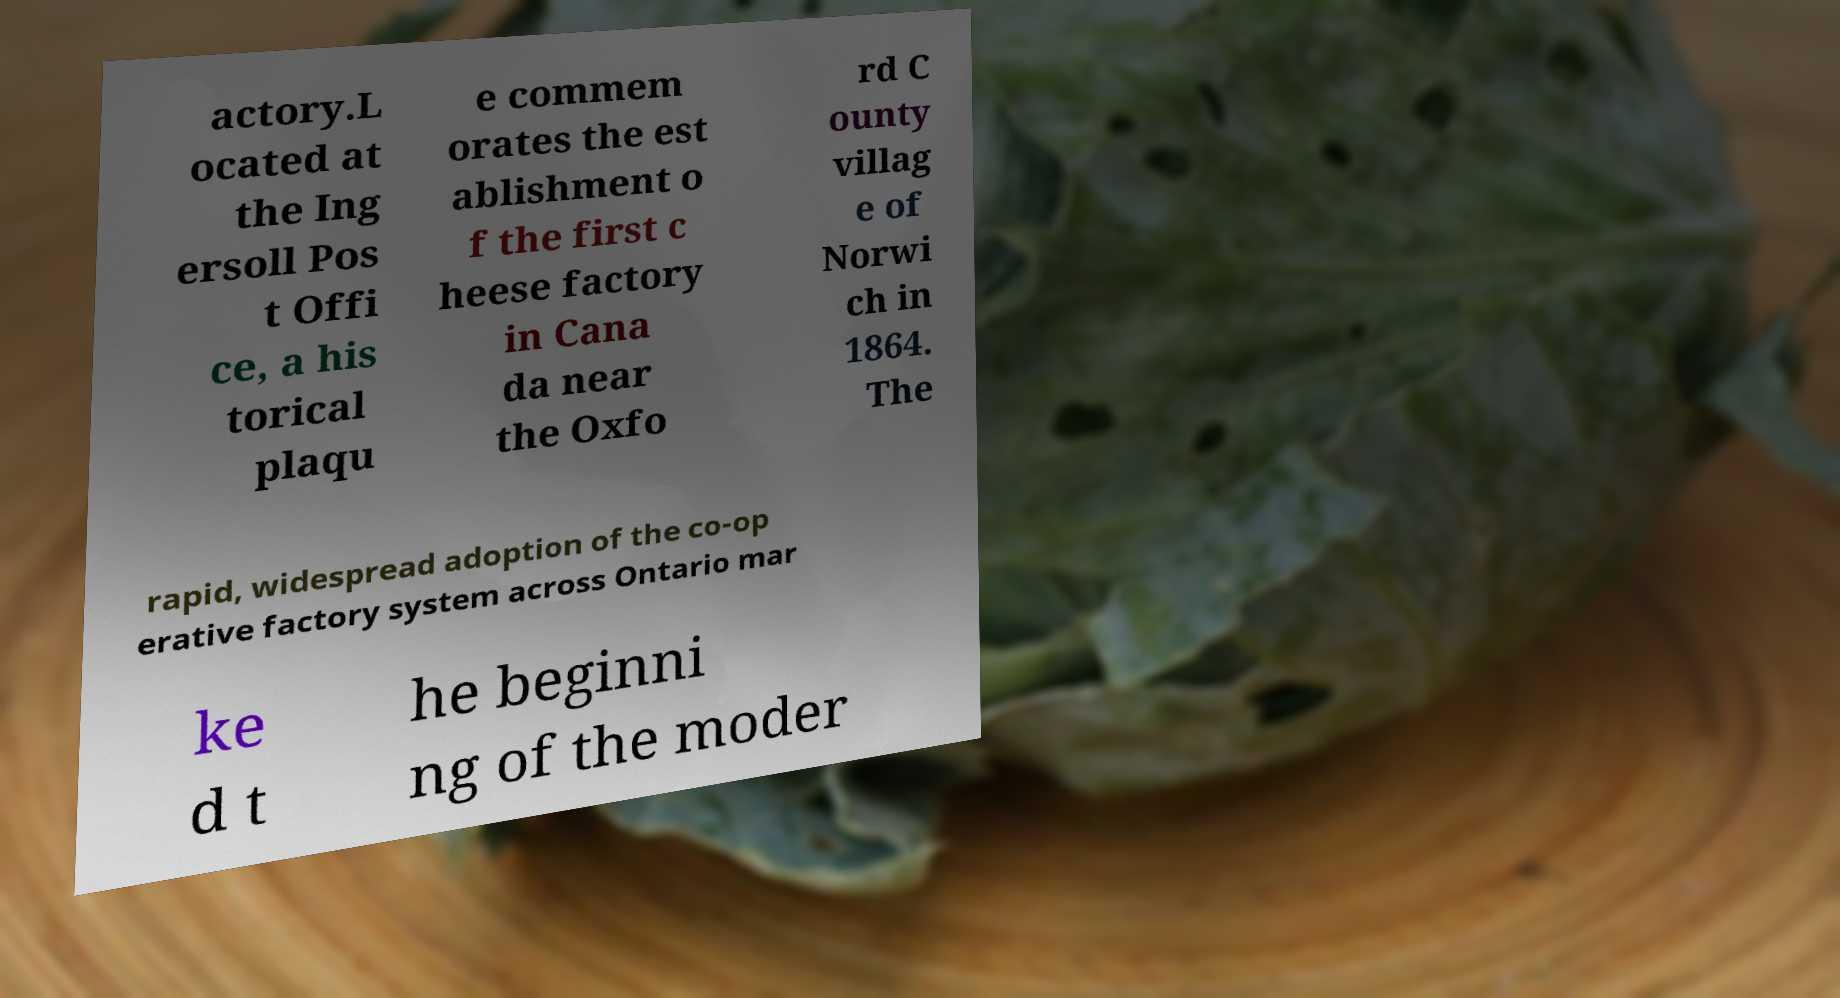There's text embedded in this image that I need extracted. Can you transcribe it verbatim? actory.L ocated at the Ing ersoll Pos t Offi ce, a his torical plaqu e commem orates the est ablishment o f the first c heese factory in Cana da near the Oxfo rd C ounty villag e of Norwi ch in 1864. The rapid, widespread adoption of the co-op erative factory system across Ontario mar ke d t he beginni ng of the moder 